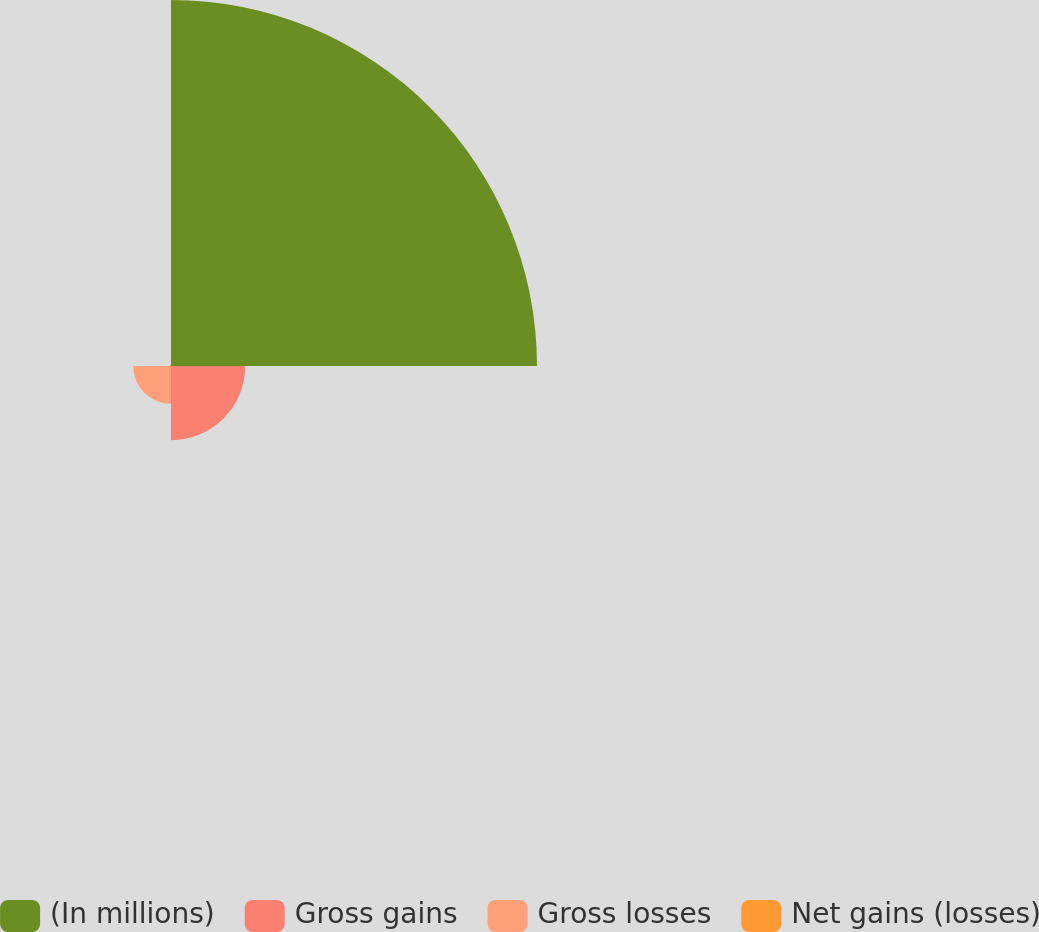<chart> <loc_0><loc_0><loc_500><loc_500><pie_chart><fcel>(In millions)<fcel>Gross gains<fcel>Gross losses<fcel>Net gains (losses)<nl><fcel>76.37%<fcel>15.49%<fcel>7.88%<fcel>0.27%<nl></chart> 